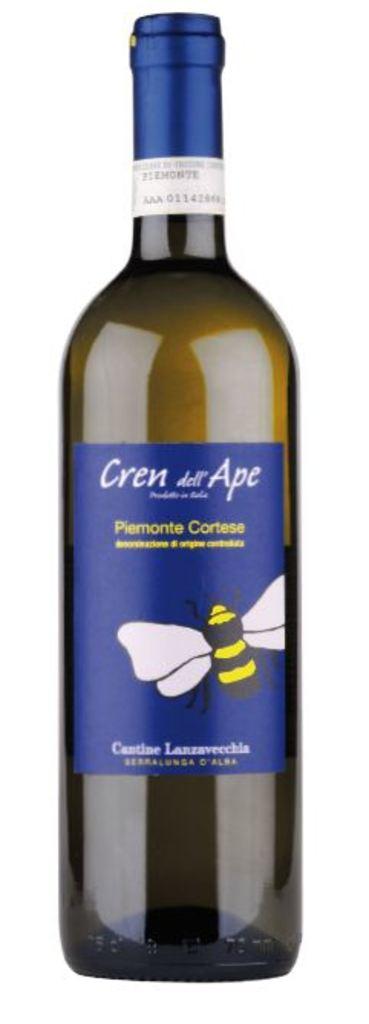What's the name on the bottle?
Provide a succinct answer. Cren de ape. 